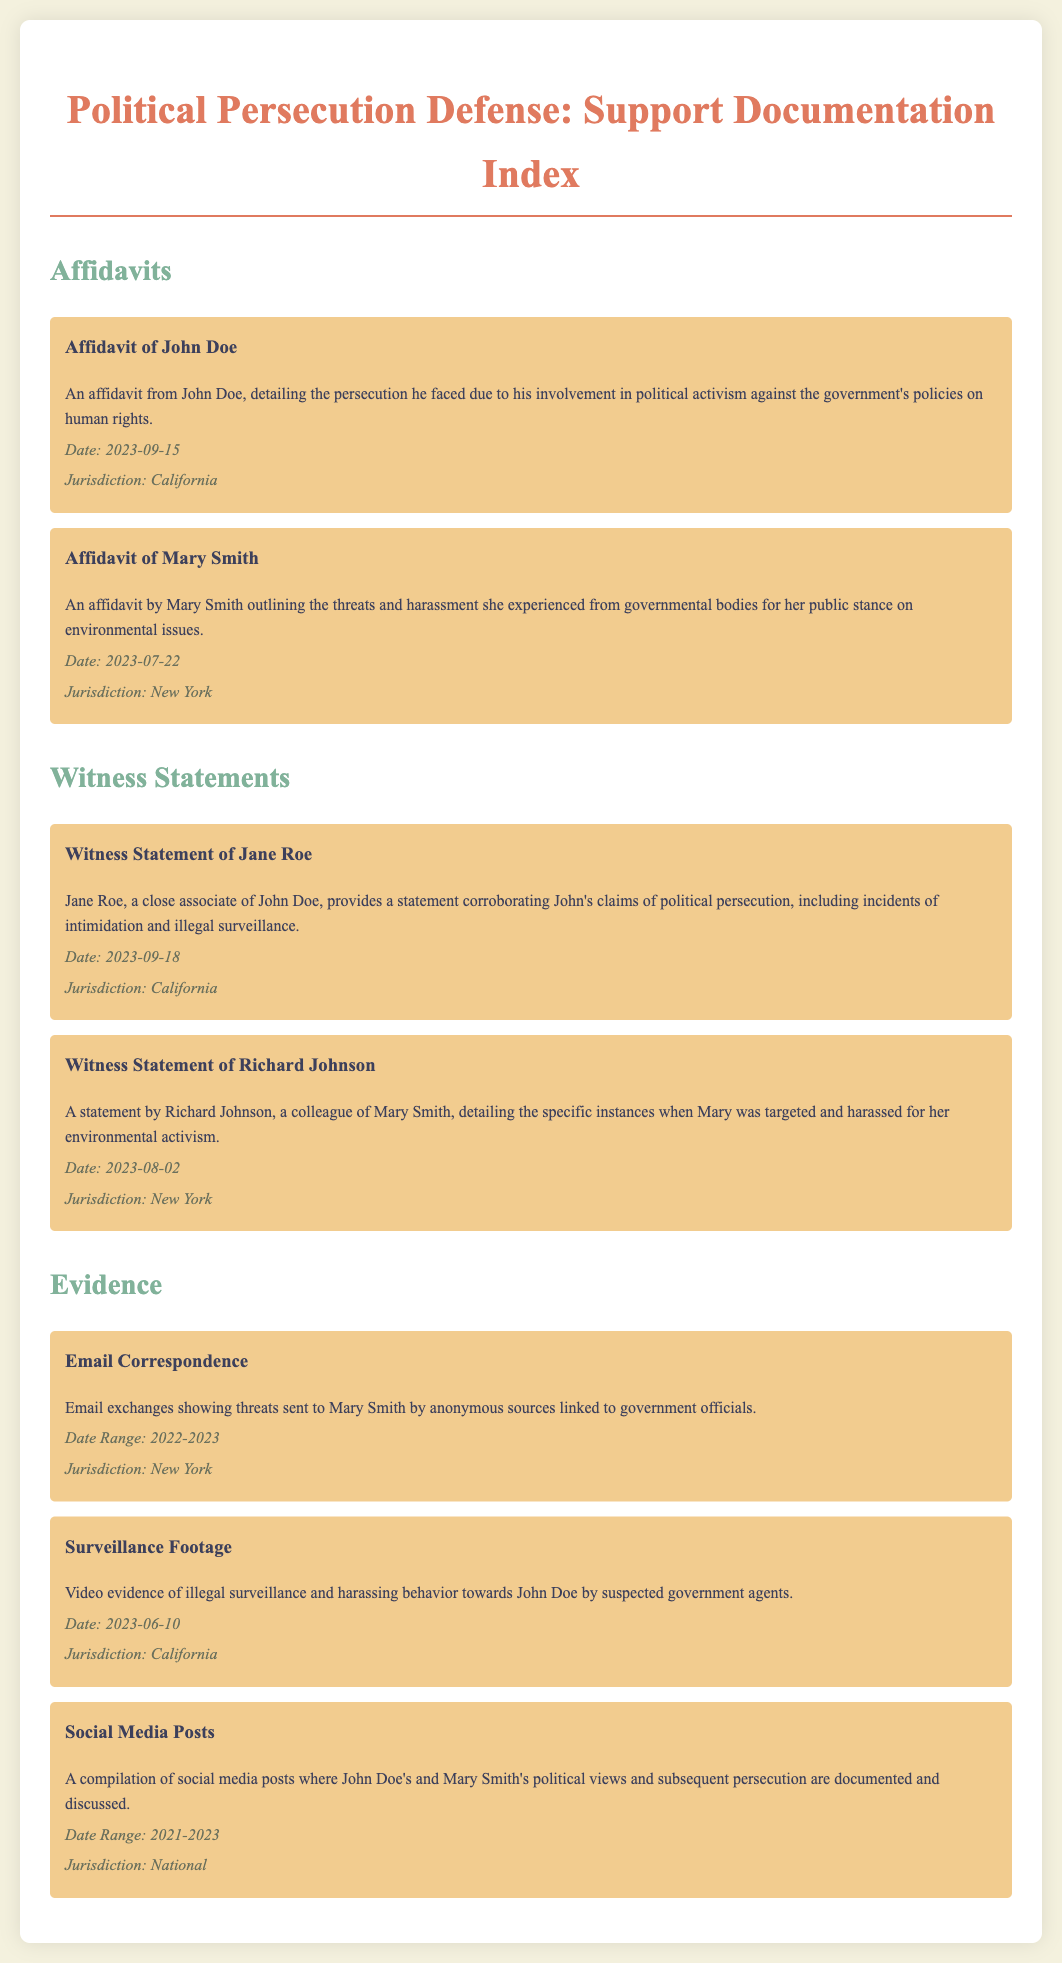What is the title of the document? The title of the document is displayed prominently at the top of the rendered HTML, summarizing its purpose regarding support documentation in political persecution defense.
Answer: Political Persecution Defense: Support Documentation Index Who is the author of the affidavit detailing persecution due to activism? The document lists John Doe as the individual who authored an affidavit about experiencing persecution linked to his political activism.
Answer: John Doe When was Mary Smith's affidavit completed? The document provides the completion date of Mary Smith's affidavit as stated below her name and summary.
Answer: 2023-07-22 What type of evidence is associated with John Doe? The rendered document specifies the type of evidence against John Doe as surveillance footage, indicating a governmental interest in monitoring his activities.
Answer: Surveillance Footage Which jurisdiction is associated with Jane Roe's witness statement? The document mentions the jurisdiction relevant to Jane Roe's statement, indicating where the events took place.
Answer: California What form of evidence highlights threats against Mary Smith? The document describes the type of evidence linking to Mary Smith as email correspondence, which documents threats she received.
Answer: Email Correspondence What incident does Richard Johnson's statement cover? Richard Johnson's statement covers specific incidents involving harassment targeted at Mary Smith, related to her activism.
Answer: Harassment What is the date of the surveillance footage? The document clearly states the date associated with the surveillance footage related to John Doe.
Answer: 2023-06-10 What theme is prevalent in the social media posts? The document indicates that the social media posts revolve around John Doe's and Mary Smith's political beliefs and the consequent persecution they faced.
Answer: Political views and persecution 